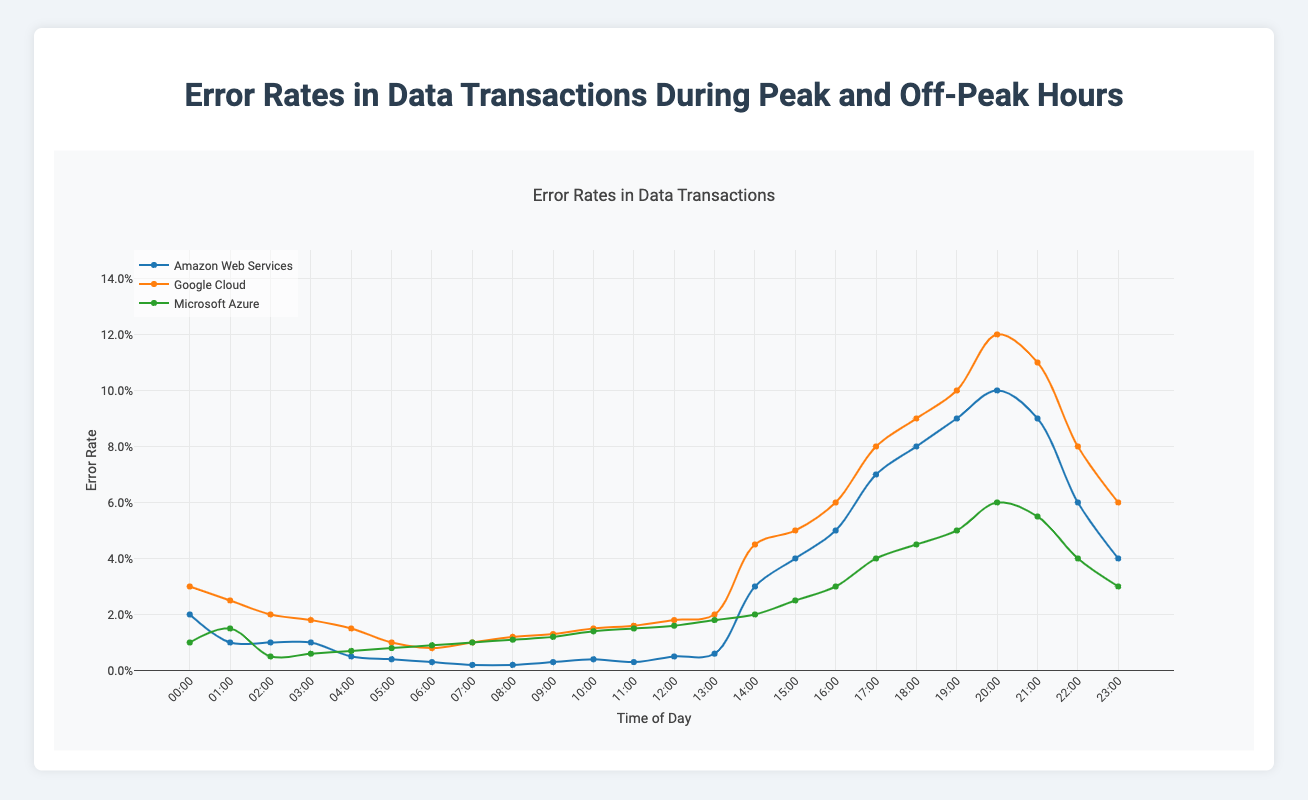Which platform has the highest error rate during peak hours? Look at the peak hour data for each platform and compare their highest values. Google Cloud has the highest peak hour error rate of 0.12 (from 20:00 - 21:00).
Answer: Google Cloud During which time period does Amazon Web Services (AWS) experience the highest error rate? Check the error rates for AWS during each time period. The highest error rate is 0.10 during the 20:00 - 21:00 period.
Answer: 20:00 - 21:00 What is the average error rate for Google Cloud during off-peak hours? Sum the off-peak hour error rates for Google Cloud and divide by the number of time periods. The sum is 0.193, and there are 12 periods, so the average is 0.193/12 = 0.0161.
Answer: 0.0161 Which platform shows the least variation in error rates between peak and off-peak hours? Compare the range (difference between highest and lowest values) of error rates for each platform between peak and off-peak hours. AWS has the least variation with a peak range of 0.02 to 0.10 and an off-peak range of 0.002 to 0.010, indicating similar ranges.
Answer: Amazon Web Services How does the error rate at 00:00 compare between peak and off-peak hours across all platforms? For each platform, compare the error rate at the start of peak hours (00:00) with off-peak hours that have the nearest time stamp post peak (02:00). AWS: 0.02 vs 0.01, Google Cloud: 0.03 vs 0.02, Microsoft Azure: 0.01 vs 0.005. In all cases, the 00:00 error rates are higher.
Answer: Higher during peak hours What is the combined error rate for Microsoft Azure from 18:00 to 20:00 during peak hours? Sum the error rates for Microsoft Azure from 18:00 to 20:00. Error rates: 0.045 (18:00-19:00) + 0.05 (19:00-20:00) = 0.095.
Answer: 0.095 Compare the peak error rate between AWS at 17:00 and Google Cloud at 23:00. Look at the error rates at these specific times. AWS (17:00 - 18:00): 0.07, Google Cloud (23:00 - 00:00): 0.06. Compare 0.07 and 0.06; AWS has a higher rate at 17:00.
Answer: AWS has a higher rate What time period has the lowest error rate for Microsoft Azure during off-peak hours? Identify the lowest error rate during off-peak hours for Microsoft Azure. The minimum value is 0.005 during the 02:00 - 03:00 period.
Answer: 02:00 - 03:00 On which platform and during which hour is the error rate 0.015? Identify times and platforms where the error rate is 0.015. For Microsoft Azure, this is at 01:00 - 02:00 (peak) and 11:00 - 12:00 (off-peak). For Google Cloud, it is off-peak hours from 10:00 - 11:00.
Answer: Multiple times and platforms (Azure: 01:00-02:00, 11:00-12:00; Google Cloud: 10:00-11:00) What is the peak hour error trend for Google Cloud from 17:00 to 21:00? Examine the trend for Google Cloud error rates during each hour from 17:00 to 21:00 (0.08 at 17:00, 0.09 at 18:00, 0.10 at 19:00, 0.12 at 20:00, 0.11 at 21:00). The trend shows an initial increase to a peak at 20:00, then a slight decrease at 21:00.
Answer: Increasing, peaks at 20:00, then decreases 